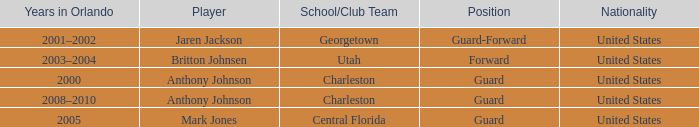Who occupied the guard-forward position as a player? Jaren Jackson. 